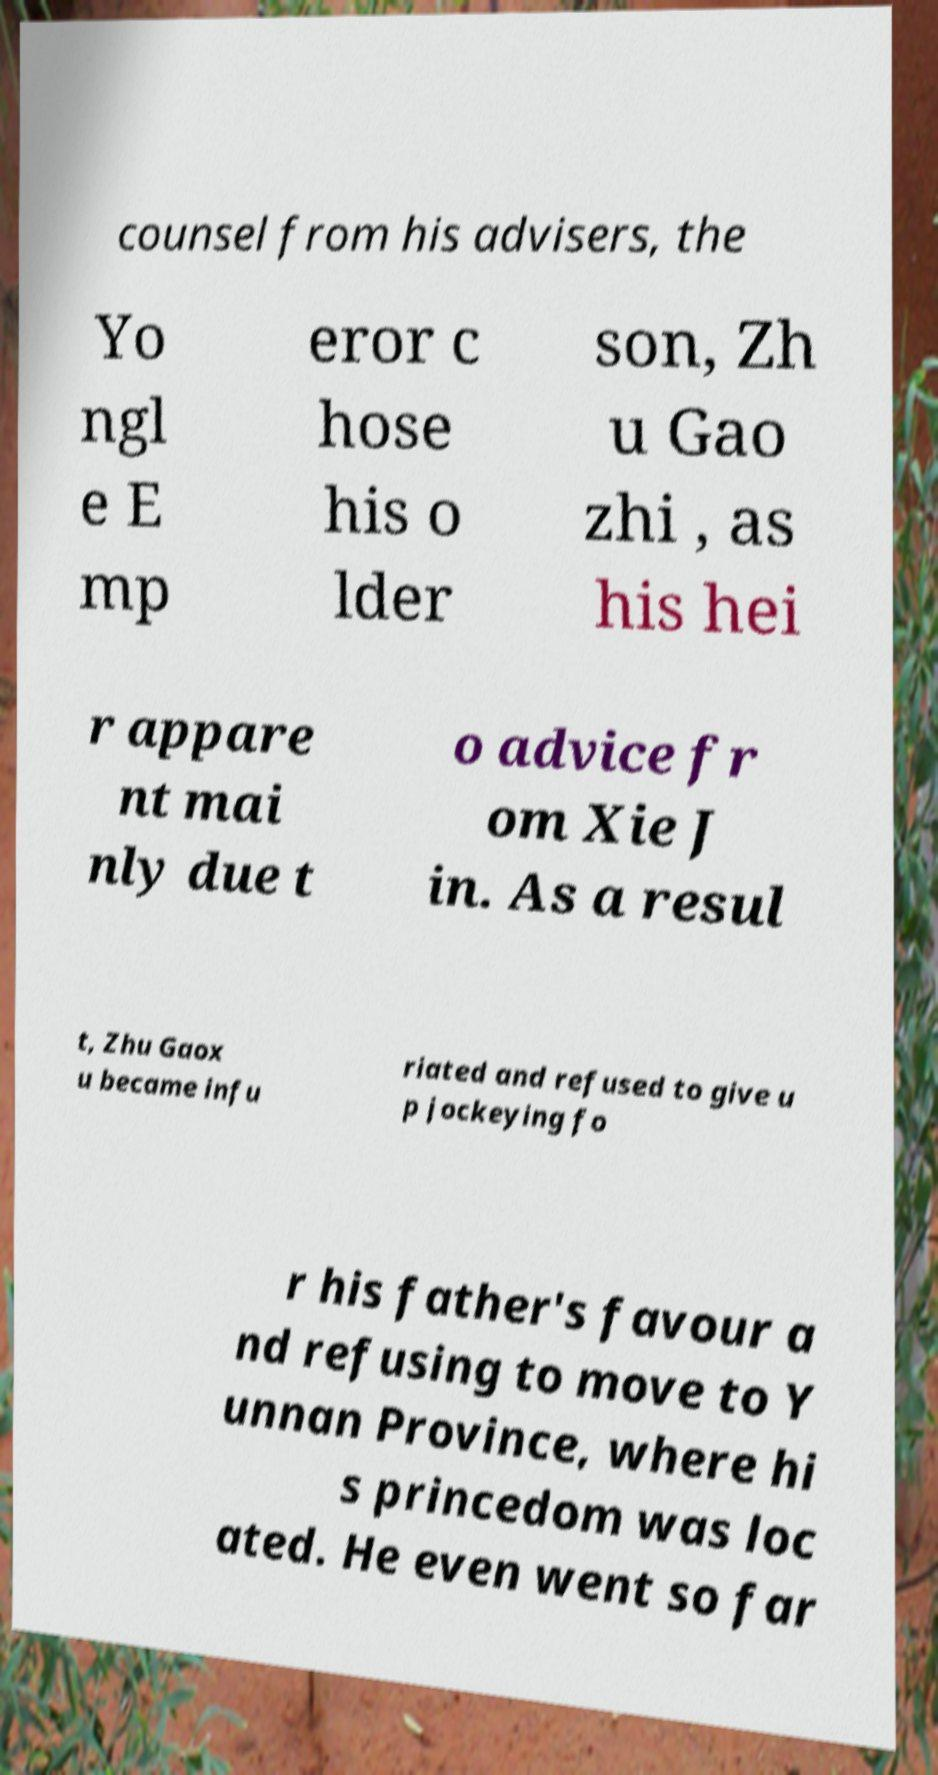For documentation purposes, I need the text within this image transcribed. Could you provide that? counsel from his advisers, the Yo ngl e E mp eror c hose his o lder son, Zh u Gao zhi , as his hei r appare nt mai nly due t o advice fr om Xie J in. As a resul t, Zhu Gaox u became infu riated and refused to give u p jockeying fo r his father's favour a nd refusing to move to Y unnan Province, where hi s princedom was loc ated. He even went so far 